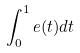<formula> <loc_0><loc_0><loc_500><loc_500>\int _ { 0 } ^ { 1 } e ( t ) d t</formula> 